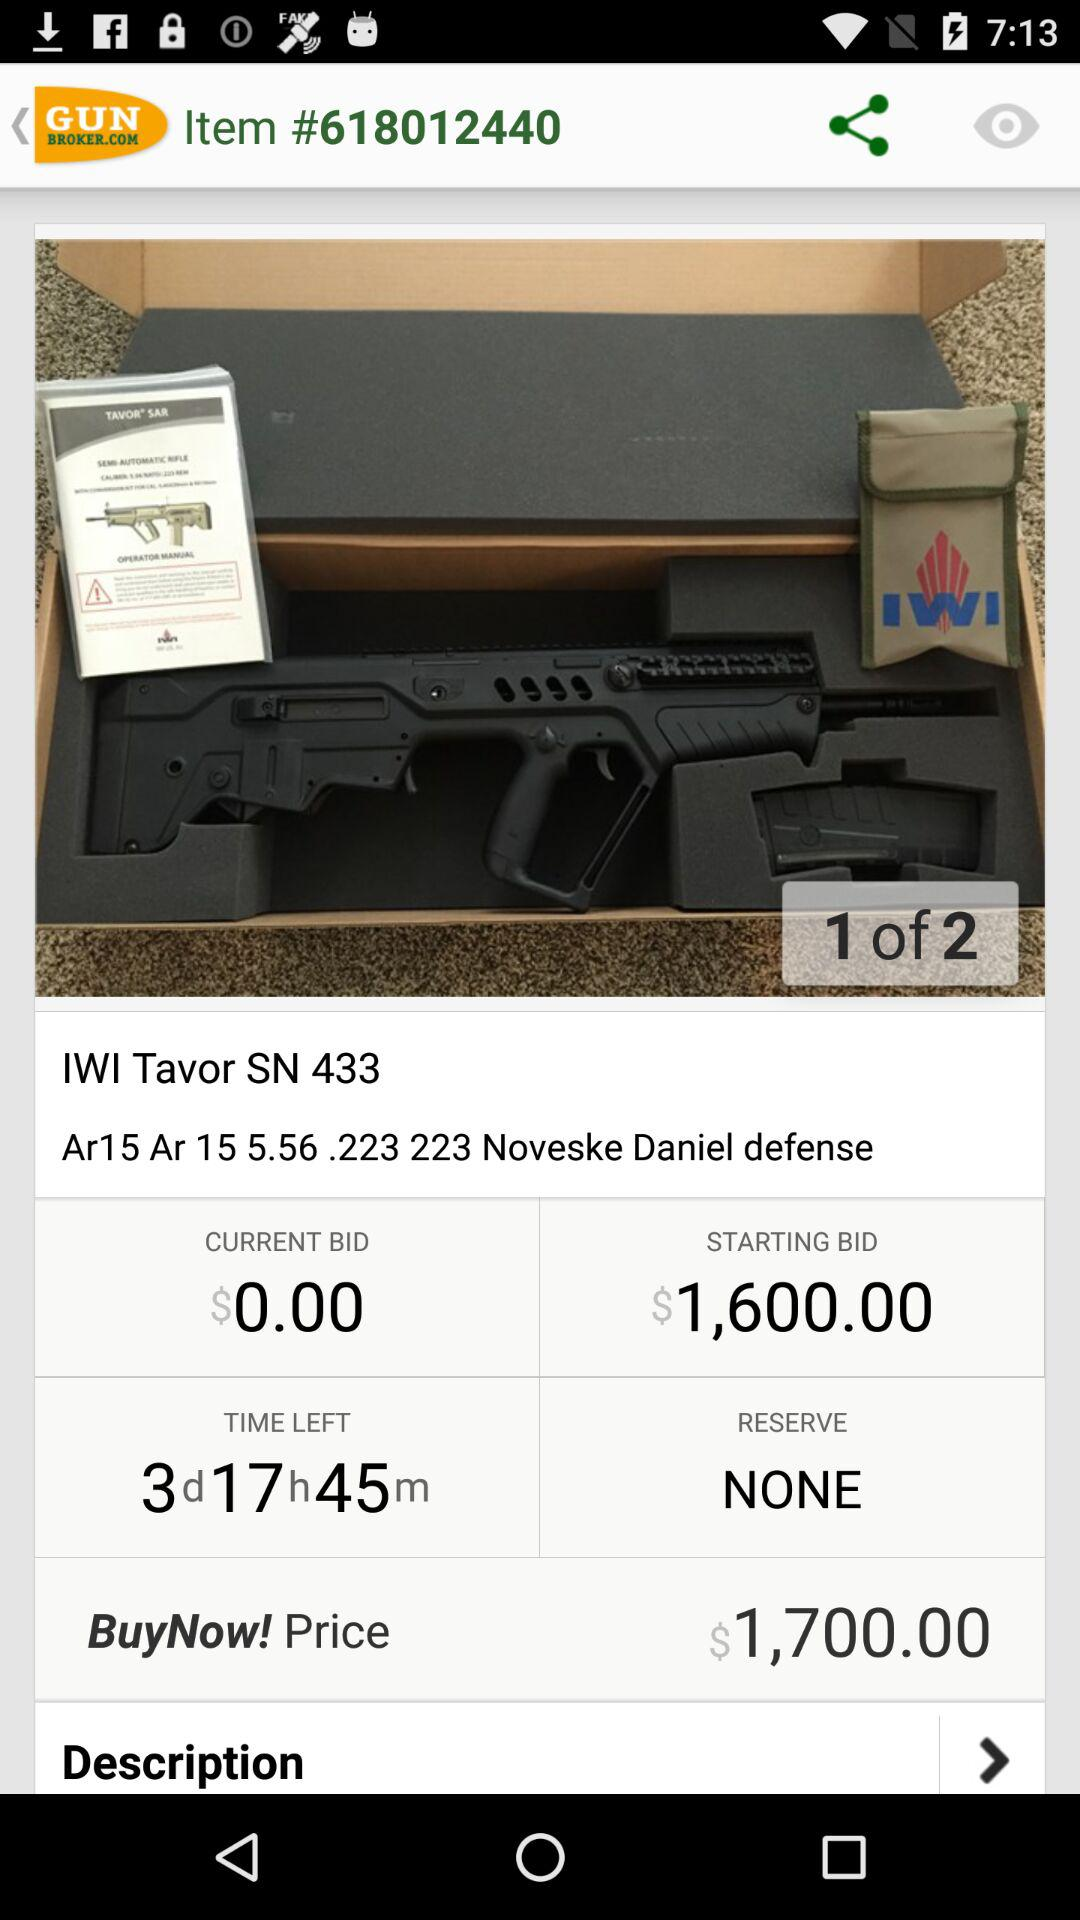What is the given item code? The given item code is 618012440. 